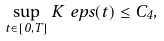<formula> <loc_0><loc_0><loc_500><loc_500>\sup _ { t \in [ 0 , T ] } K _ { \ } e p s ( t ) \leq C _ { 4 } ,</formula> 